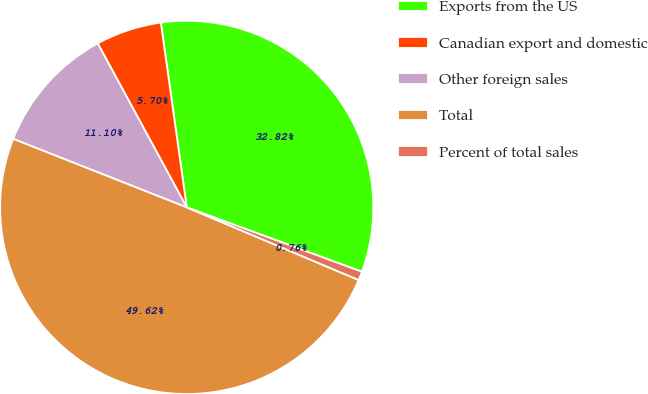Convert chart. <chart><loc_0><loc_0><loc_500><loc_500><pie_chart><fcel>Exports from the US<fcel>Canadian export and domestic<fcel>Other foreign sales<fcel>Total<fcel>Percent of total sales<nl><fcel>32.82%<fcel>5.7%<fcel>11.1%<fcel>49.62%<fcel>0.76%<nl></chart> 